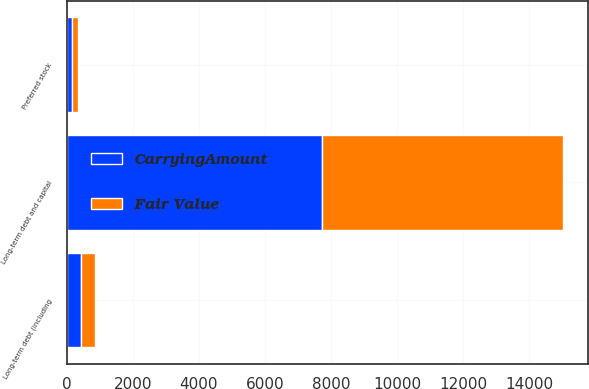Convert chart. <chart><loc_0><loc_0><loc_500><loc_500><stacked_bar_chart><ecel><fcel>Long-term debt and capital<fcel>Preferred stock<fcel>Long-term debt (including<nl><fcel>Fair Value<fcel>7317<fcel>195<fcel>421<nl><fcel>CarryingAmount<fcel>7719<fcel>150<fcel>436<nl></chart> 